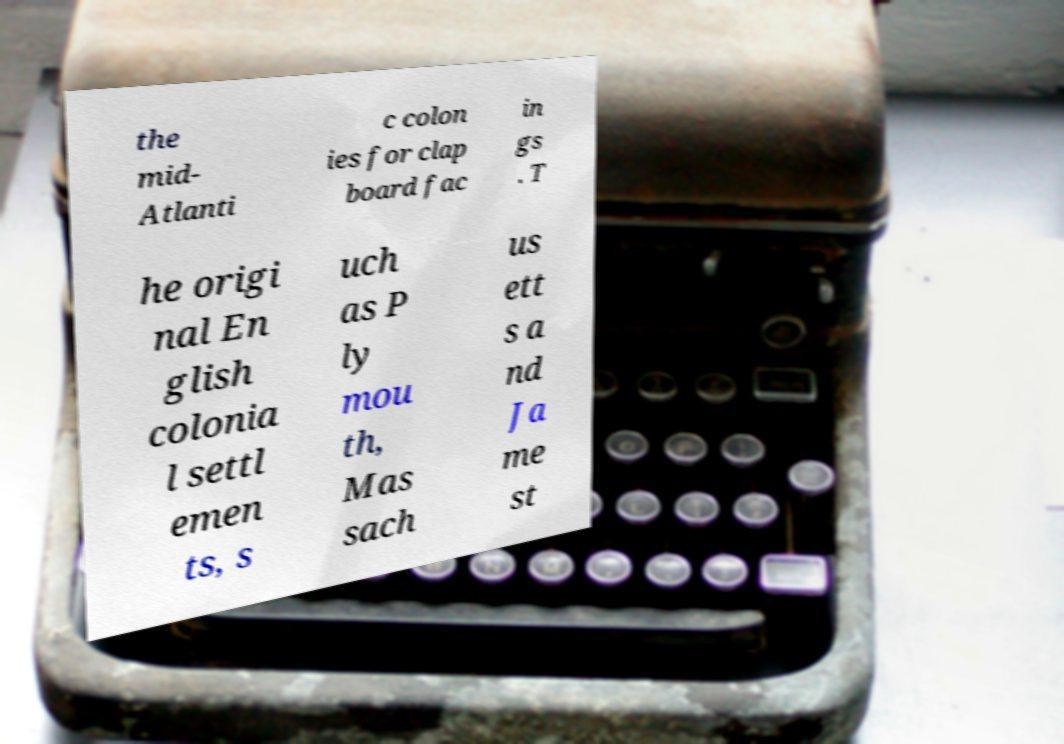I need the written content from this picture converted into text. Can you do that? the mid- Atlanti c colon ies for clap board fac in gs . T he origi nal En glish colonia l settl emen ts, s uch as P ly mou th, Mas sach us ett s a nd Ja me st 